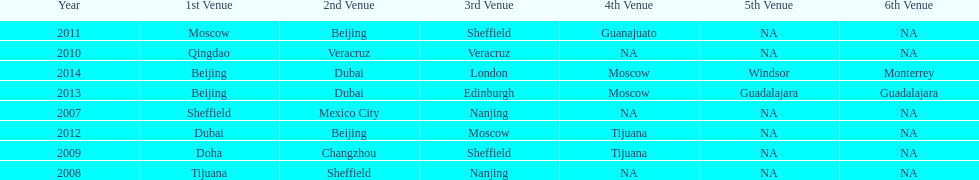Which year had more venues, 2007 or 2012? 2012. 